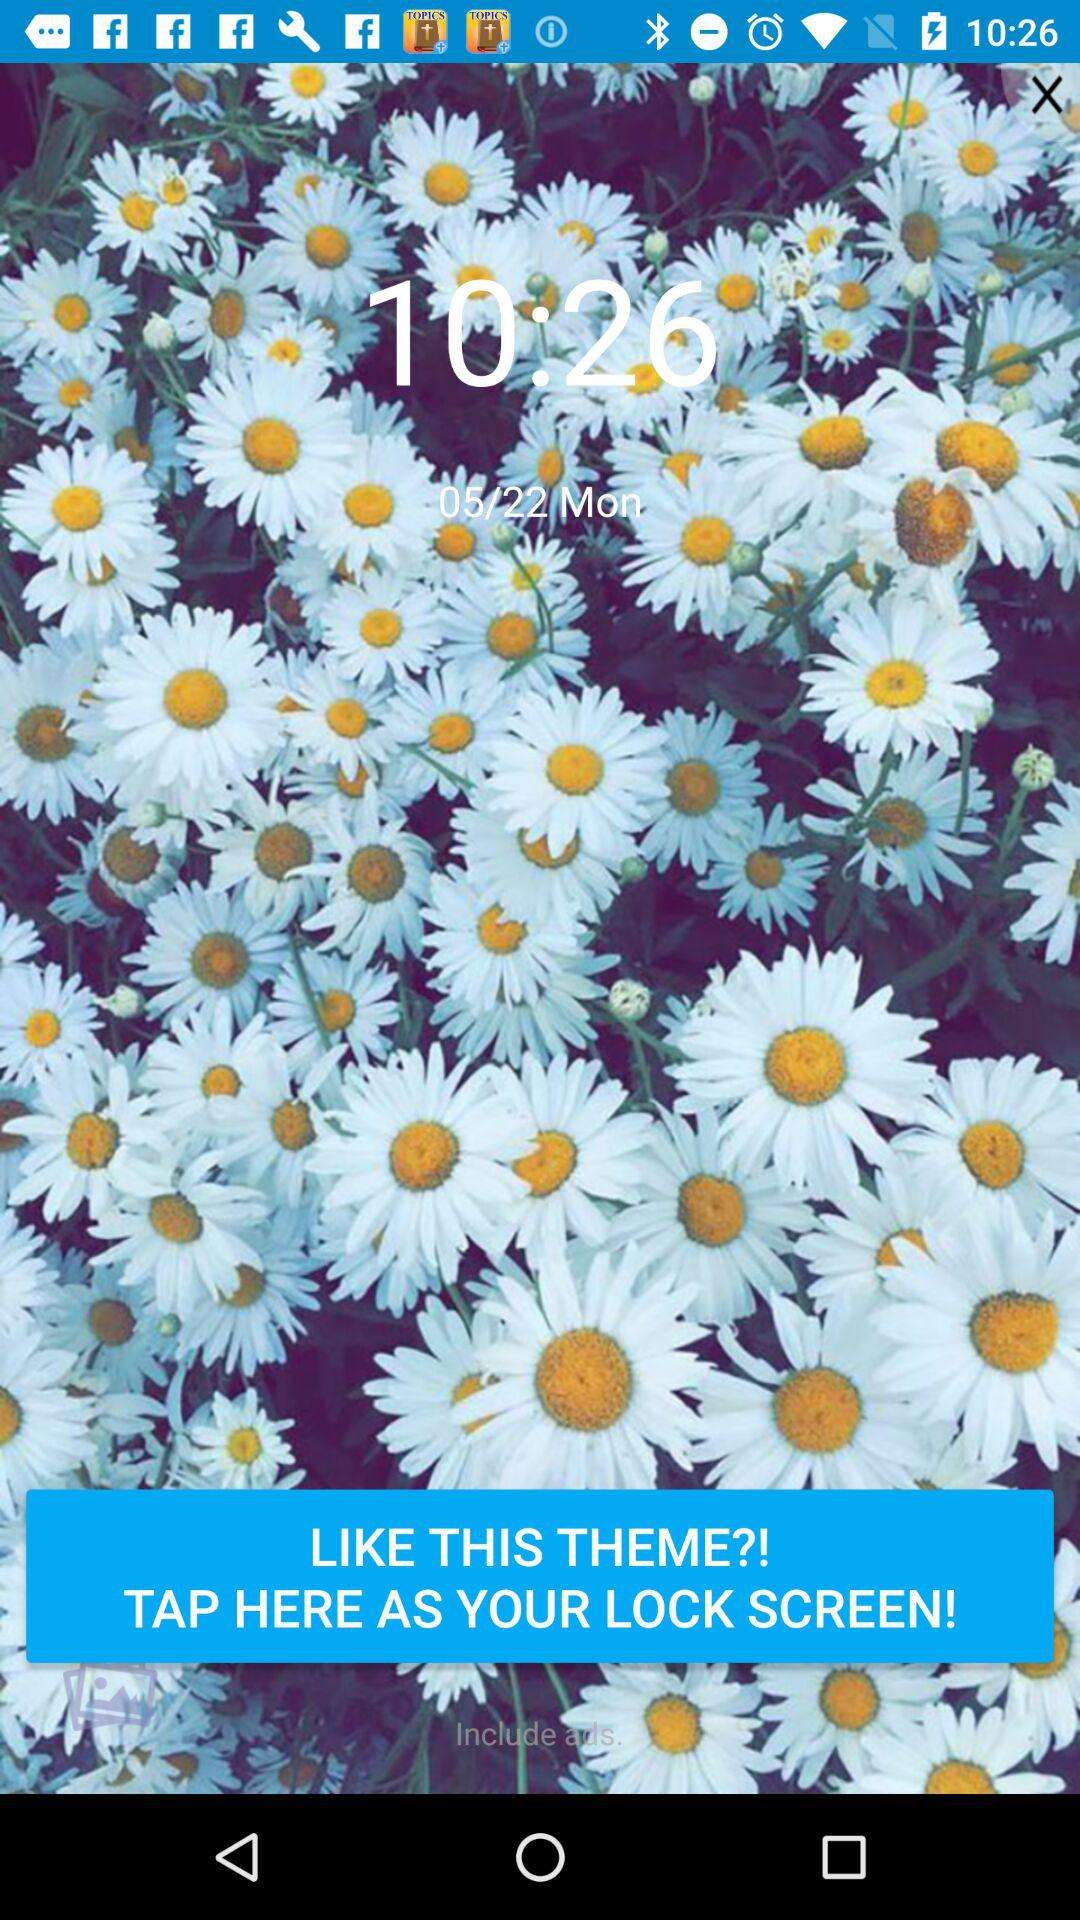What is the given time in the wallpaper? The given time is 10:26. 